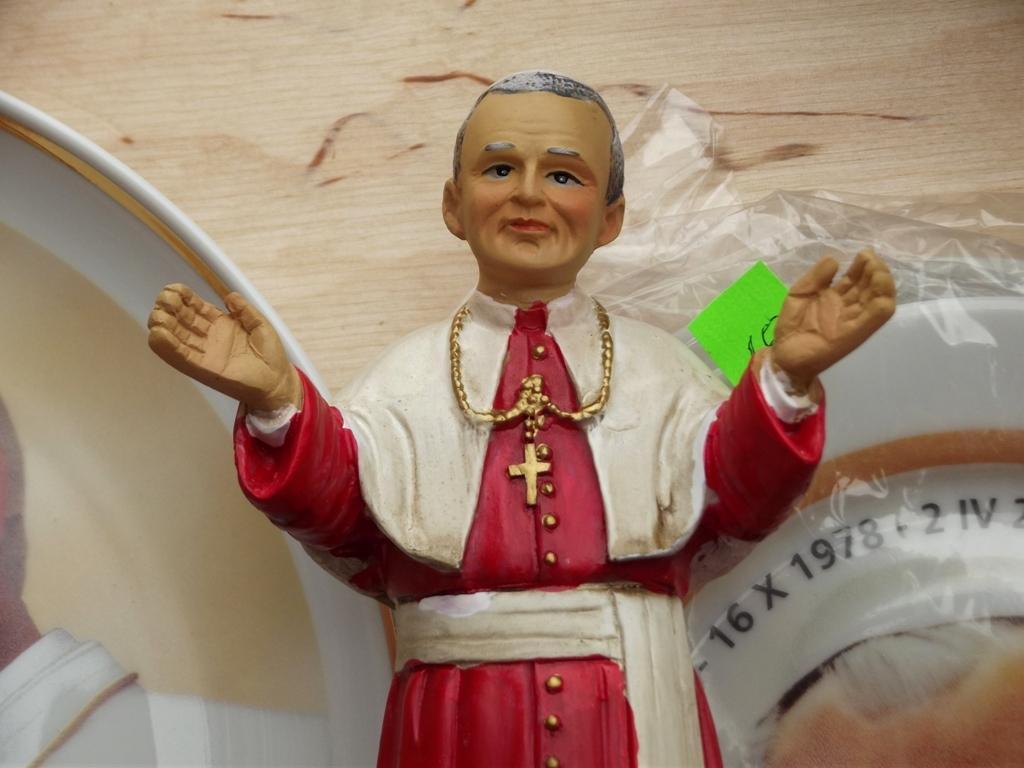In one or two sentences, can you explain what this image depicts? In the image there is a small toy of a church father, behind the toy there are other objects. 